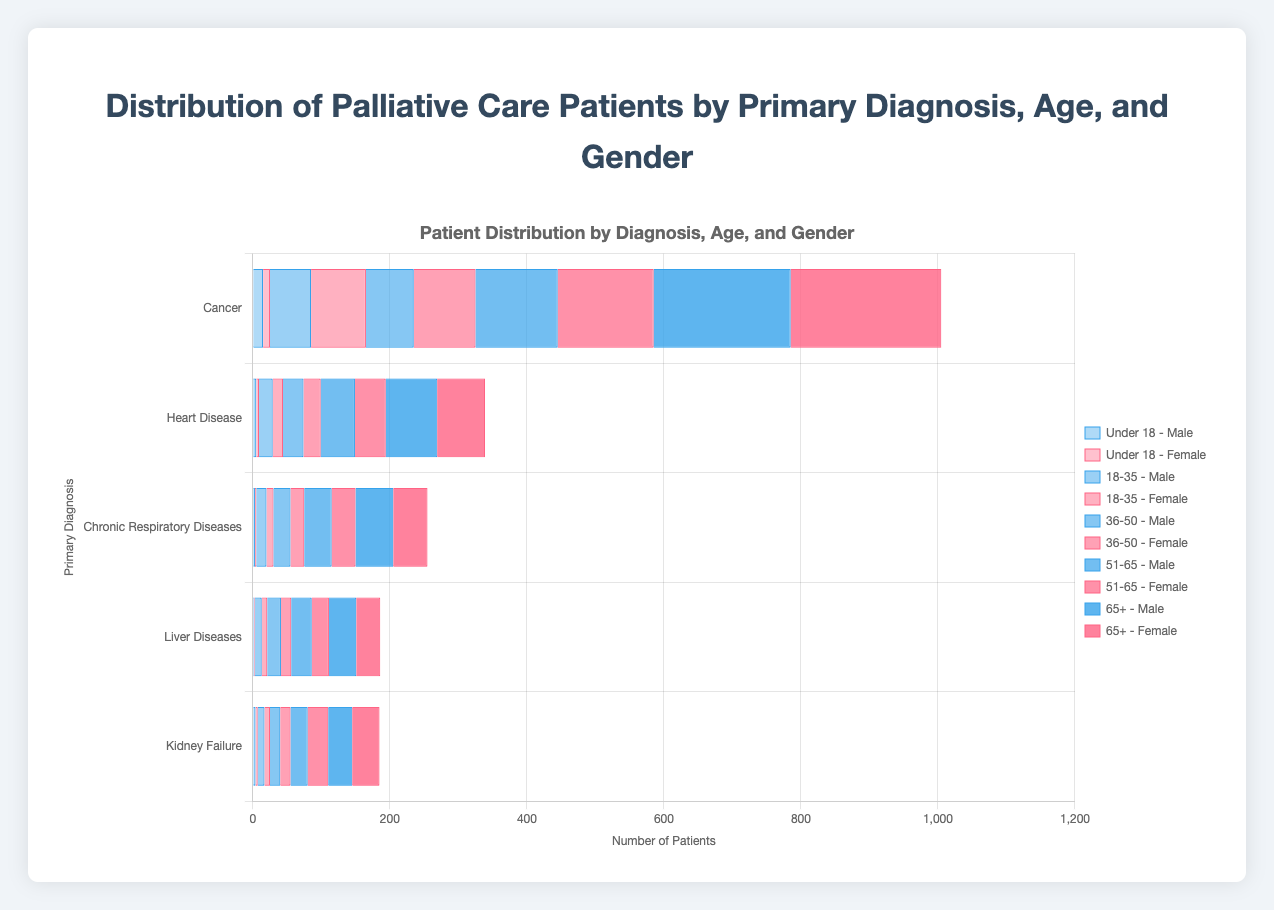What is the total number of male patients across all age groups for Cancer? First, extract the male patient numbers for Cancer from each age group: 15 (Under 18), 60 (18-35), 70 (36-50), 120 (51-65), 200 (65+). Then, sum these numbers: 15 + 60 + 70 + 120 + 200 = 465
Answer: 465 Which age group has the highest number of female patients with Chronic Respiratory Diseases? Look at the female patient numbers with Chronic Respiratory Diseases by age group: 2 (Under 18), 10 (18-35), 20 (36-50), 35 (51-65), 50 (65+). The highest number is 50 in the 65+ age group
Answer: 65+ What is the difference in the number of female patients with Cancer between age groups 36-50 and 51-65? Extract the female patient numbers for Cancer in the 36-50 age group (90) and the 51-65 age group (140). Then, calculate the difference: 140 - 90 = 50
Answer: 50 How many total patients suffer from Heart Disease in the 18-35 age group? Add the male and female Heart Disease patient numbers for the 18-35 age group: 20 (Male) + 15 (Female) = 35
Answer: 35 Which gender has a higher number of patients with Liver Diseases in the 51-65 age group, and by how much? Check the patient numbers for Liver Diseases in the 51-65 age group: 30 (Male) and 25 (Female). Males have more patients: 30 - 25 = 5
Answer: Male, by 5 Are there more male or female patients with Kidney Failure under 18? Compare the patient numbers for Kidney Failure under 18: 4 (Male) and 3 (Female). Males have more patients
Answer: Male Which primary diagnosis has the fewest total patients across all age groups? Sum the total number of patients for each diagnosis:
Cancer: 615 (male) + 540 (female) = 1155
Heart Disease: 180 (male) + 159 (female) = 339
Chronic Respiratory Diseases: 138 (male) + 117 (female) = 255
Liver Diseases: 102 (male) + 84 (female) = 186
Kidney Failure: 89 (male) + 96 (female) = 185
Liver Diseases, with 186 total patients, is the fewest
Answer: Liver Diseases What is the average number of female patients with Cancer aged 18-65? Extract the female patient numbers for Cancer in the 18-35 (80), 36-50 (90), and 51-65 (140) age groups. Calculate the average: (80 + 90 + 140) / 3 = 103.33
Answer: 103.33 In the 65+ age group, which diagnosis has a higher number of female patients compared to male patients? Compare female and male patient numbers in the 65+ age group for each diagnosis:
Cancer: Male: 200, Female: 220 (Female is higher)
Heart Disease: Male: 75, Female: 70 (Male is higher)
Chronic Respiratory Diseases: Male: 55, Female: 50 (Male is higher)
Liver Diseases: Male: 40, Female: 35 (Male is higher)
Kidney Failure: Male: 35, Female: 40 (Female is higher)
Both Cancer and Kidney Failure have higher female patients, with Cancer having a larger difference
Answer: Cancer and Kidney Failure 